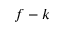<formula> <loc_0><loc_0><loc_500><loc_500>f - k</formula> 